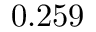<formula> <loc_0><loc_0><loc_500><loc_500>0 . 2 5 9</formula> 